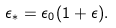Convert formula to latex. <formula><loc_0><loc_0><loc_500><loc_500>\epsilon _ { \ast } = \epsilon _ { 0 } ( 1 + \epsilon ) .</formula> 